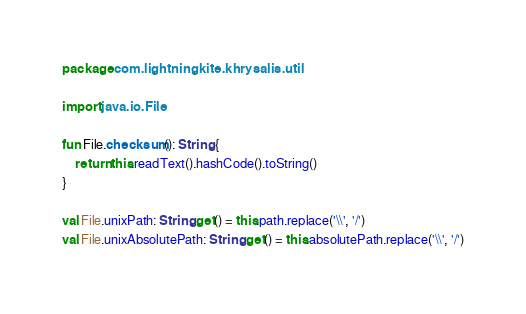<code> <loc_0><loc_0><loc_500><loc_500><_Kotlin_>package com.lightningkite.khrysalis.util

import java.io.File

fun File.checksum(): String {
    return this.readText().hashCode().toString()
}

val File.unixPath: String get() = this.path.replace('\\', '/')
val File.unixAbsolutePath: String get() = this.absolutePath.replace('\\', '/')</code> 